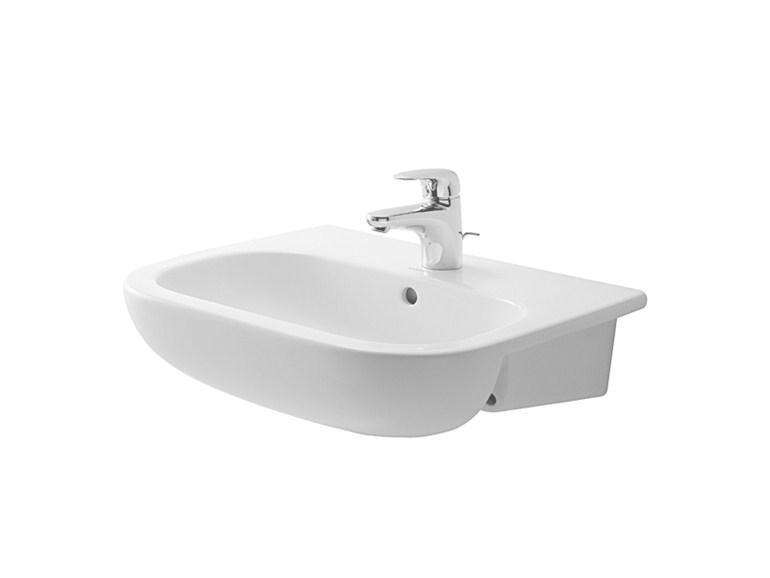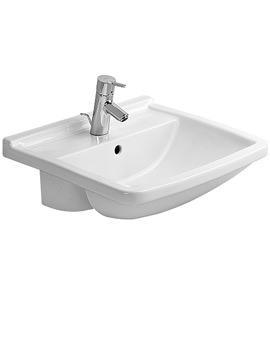The first image is the image on the left, the second image is the image on the right. Assess this claim about the two images: "One of the faucets attached to a sink is facing slightly to the right.". Correct or not? Answer yes or no. Yes. The first image is the image on the left, the second image is the image on the right. Examine the images to the left and right. Is the description "Each sink is a single-basin design inset in a white rectangle that is straight across the front." accurate? Answer yes or no. No. 